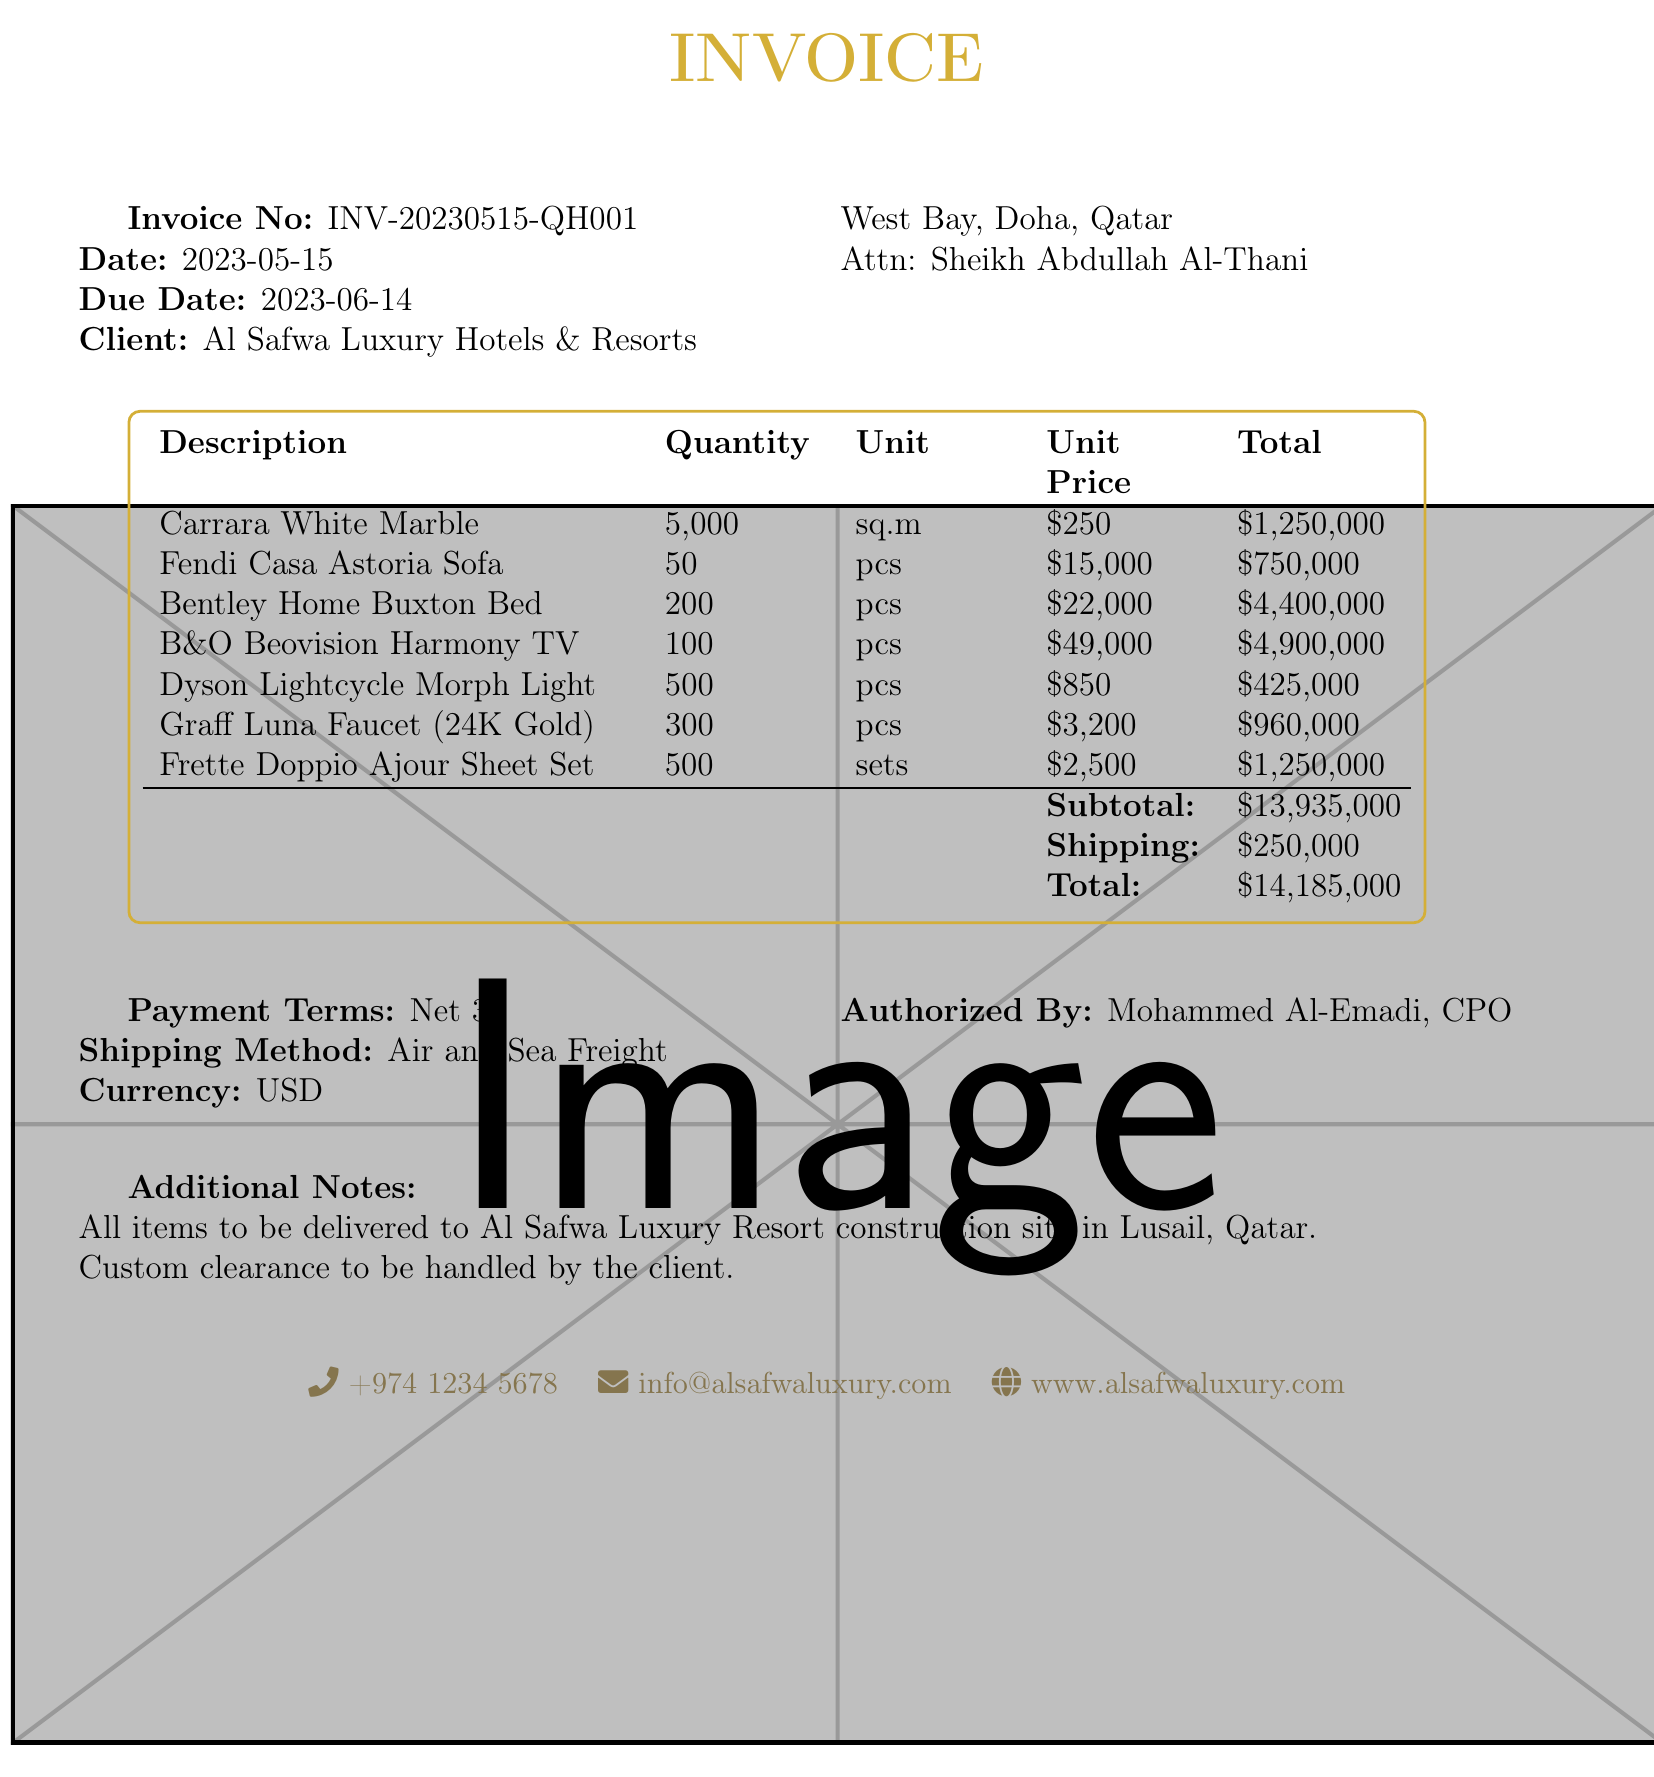What is the invoice number? The invoice number is a specific identifier for the transaction, listed in the document as INV-20230515-QH001.
Answer: INV-20230515-QH001 What is the total amount due? The total amount due is the final calculation of the entire transaction costs, specified as $14,185,000 in the document.
Answer: $14,185,000 Who is the contact person for the client? The contact person for the client is the individual mentioned in the document, which is Sheikh Abdullah Al-Thani.
Answer: Sheikh Abdullah Al-Thani How many pieces of Bentley Home Buxton Bed are ordered? The number of pieces ordered for the Bentley Home Buxton Bed is provided as 200 in the items section of the document.
Answer: 200 What is the shipping method specified? The shipping method refers to how the items will be delivered, detailed in the document as Air and Sea Freight.
Answer: Air and Sea Freight What is the quantity of Carrara White Marble ordered? The quantity of Carrara White Marble indicates the amount being purchased, which is detailed as 5000 square meters.
Answer: 5000 square meters What is the tax rate applied to this invoice? The tax rate is essential to understand if any additional taxes apply, and it is noted as 0 in the summary.
Answer: 0 How much is the unit price of the Dyson Lightcycle Morph Floor Light? The unit price is stated as a specific cost per item, which is listed as $850 in the document.
Answer: $850 What additional notes are provided in the invoice? Additional notes give important delivery information, stated as all items to be delivered to Al Safwa Luxury Resort construction site in Lusail, Qatar.
Answer: All items to be delivered to Al Safwa Luxury Resort construction site in Lusail, Qatar 